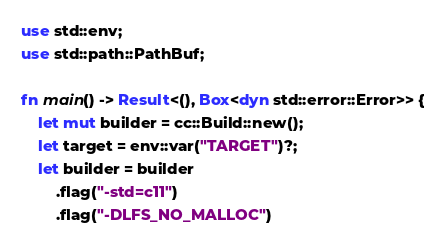<code> <loc_0><loc_0><loc_500><loc_500><_Rust_>use std::env;
use std::path::PathBuf;

fn main() -> Result<(), Box<dyn std::error::Error>> {
    let mut builder = cc::Build::new();
    let target = env::var("TARGET")?;
    let builder = builder
        .flag("-std=c11")
        .flag("-DLFS_NO_MALLOC")</code> 